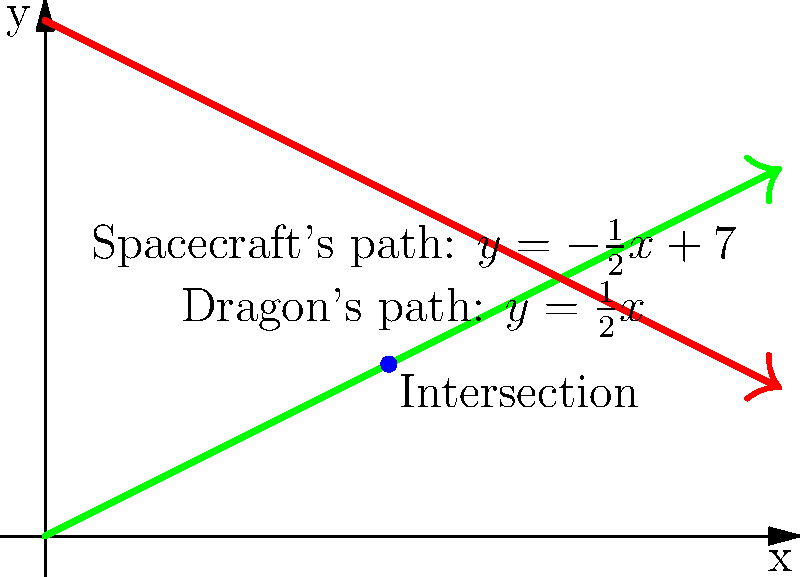In a fantasy-meets-sci-fi scenario, a dragon's flight path is represented by the equation $y = \frac{1}{2}x$, while an alien spacecraft's trajectory is given by $y = -\frac{1}{2}x + 7$. At what point do these two paths intersect? Express your answer as an ordered pair $(x, y)$. To find the intersection point, we need to solve the system of equations:

1) Dragon's path: $y = \frac{1}{2}x$
2) Spacecraft's path: $y = -\frac{1}{2}x + 7$

At the intersection point, the $y$ values are equal, so we can set the equations equal to each other:

$$\frac{1}{2}x = -\frac{1}{2}x + 7$$

Now, let's solve for $x$:

$$\frac{1}{2}x + \frac{1}{2}x = 7$$
$$x = 7$$
$$x = \frac{14}{3}$$

To find the $y$ coordinate, we can substitute this $x$ value into either equation. Let's use the dragon's path equation:

$$y = \frac{1}{2}(\frac{14}{3}) = \frac{7}{3}$$

Therefore, the intersection point is $(\frac{14}{3}, \frac{7}{3})$.
Answer: $(\frac{14}{3}, \frac{7}{3})$ 